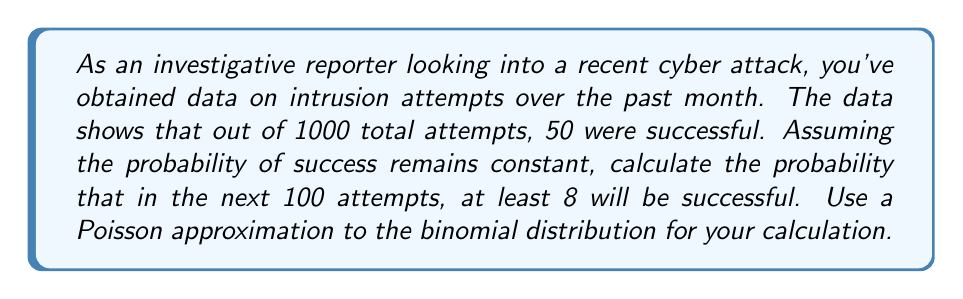Solve this math problem. To solve this problem, we'll follow these steps:

1) First, we need to calculate the probability of a single successful intrusion attempt:
   $$p = \frac{50}{1000} = 0.05$$

2) For the next 100 attempts, we can use the binomial distribution. However, since n is large (100) and p is small (0.05), we can approximate this with a Poisson distribution.

3) The parameter λ for the Poisson distribution is:
   $$λ = np = 100 * 0.05 = 5$$

4) We want to find the probability of at least 8 successes, which is equivalent to 1 minus the probability of 7 or fewer successes:

   $$P(X \geq 8) = 1 - P(X \leq 7)$$

5) Using the cumulative distribution function of the Poisson distribution:

   $$P(X \leq 7) = e^{-λ} \sum_{k=0}^{7} \frac{λ^k}{k!}$$

6) Substituting λ = 5:

   $$P(X \leq 7) = e^{-5} (1 + 5 + \frac{5^2}{2!} + \frac{5^3}{3!} + \frac{5^4}{4!} + \frac{5^5}{5!} + \frac{5^6}{6!} + \frac{5^7}{7!})$$

7) Calculating this (you would typically use a calculator or computer for this):

   $$P(X \leq 7) \approx 0.8666$$

8) Therefore:

   $$P(X \geq 8) = 1 - P(X \leq 7) \approx 1 - 0.8666 = 0.1334$$
Answer: The probability that at least 8 out of the next 100 intrusion attempts will be successful is approximately 0.1334 or 13.34%. 